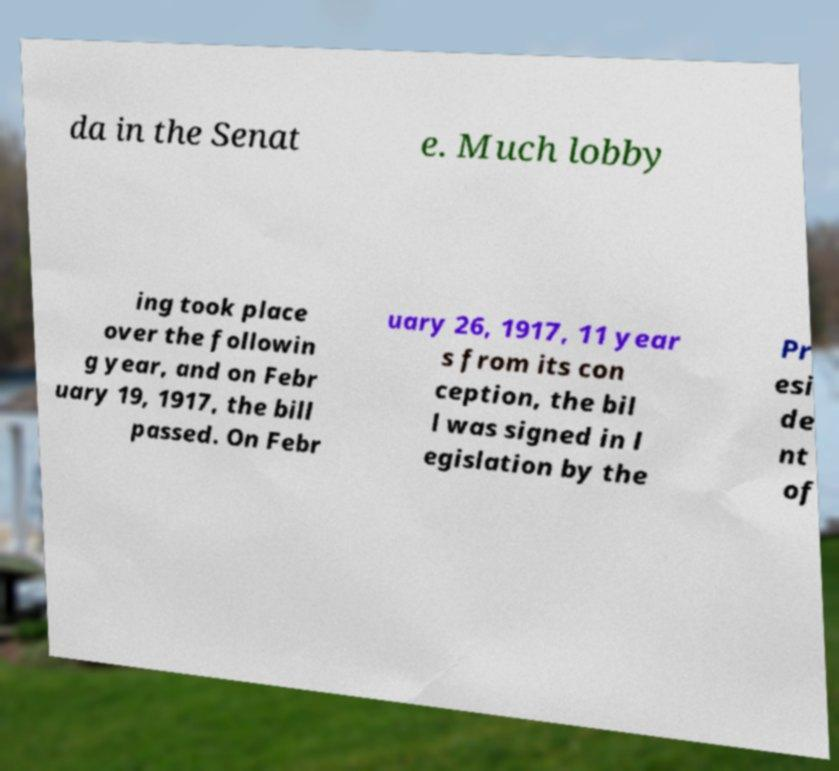Please read and relay the text visible in this image. What does it say? da in the Senat e. Much lobby ing took place over the followin g year, and on Febr uary 19, 1917, the bill passed. On Febr uary 26, 1917, 11 year s from its con ception, the bil l was signed in l egislation by the Pr esi de nt of 